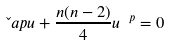<formula> <loc_0><loc_0><loc_500><loc_500>\L a p u + \frac { n ( n - 2 ) } { 4 } u ^ { \ p } = 0</formula> 